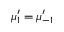Convert formula to latex. <formula><loc_0><loc_0><loc_500><loc_500>\mu _ { 1 } ^ { \prime } = \mu _ { - 1 } ^ { \prime }</formula> 